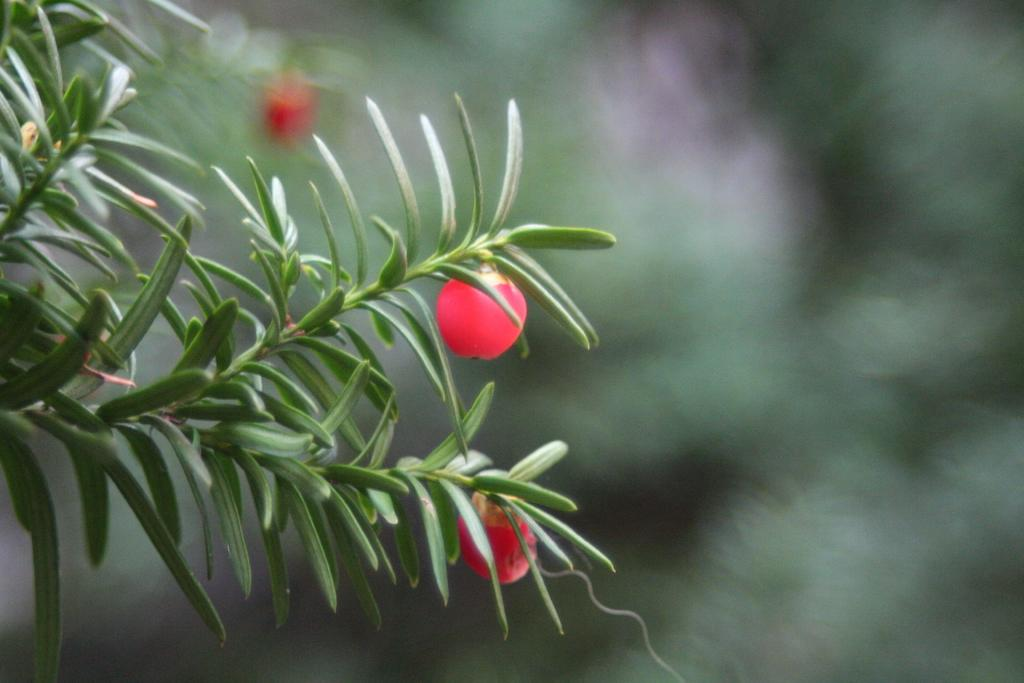What type of food items are present in the image? There are fruits in the image. What natural elements can be seen in the image? There are trees in the image. What type of balls can be seen in the image? There are no balls present in the image. What type of organization is depicted in the image? There is no organization depicted in the image; it features fruits and trees. 